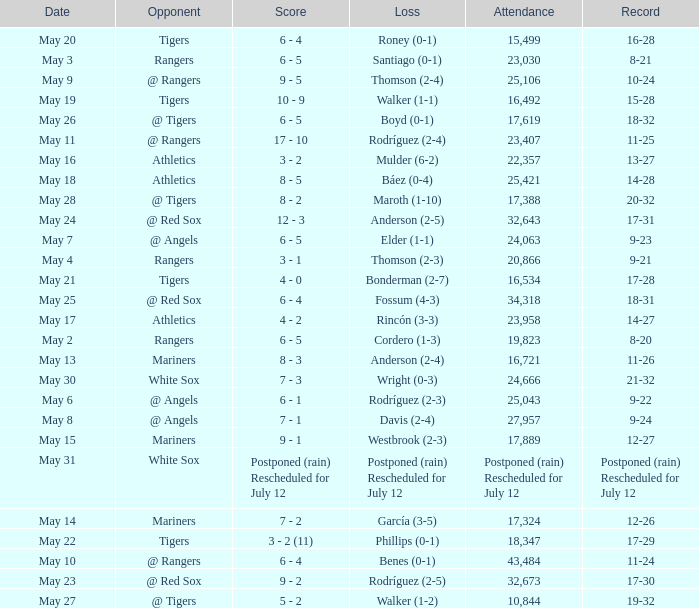What date did the Indians have a record of 14-28? May 18. 